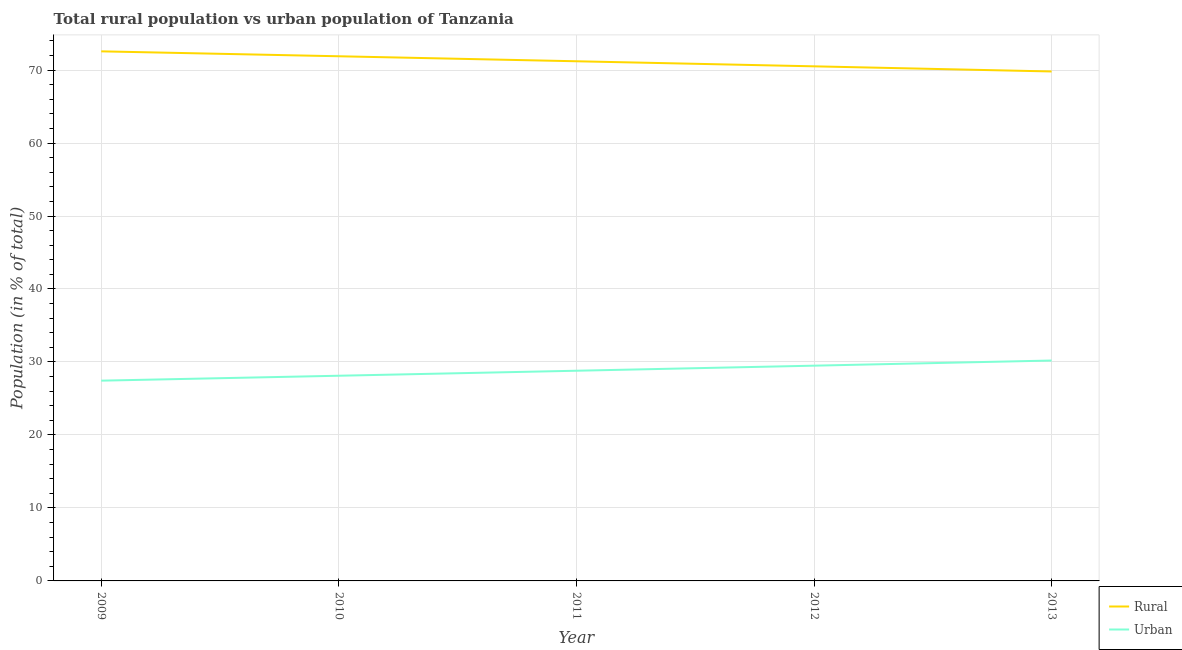Does the line corresponding to rural population intersect with the line corresponding to urban population?
Offer a very short reply. No. Is the number of lines equal to the number of legend labels?
Your response must be concise. Yes. What is the urban population in 2013?
Provide a succinct answer. 30.2. Across all years, what is the maximum rural population?
Offer a terse response. 72.56. Across all years, what is the minimum urban population?
Provide a succinct answer. 27.44. In which year was the rural population minimum?
Your answer should be compact. 2013. What is the total urban population in the graph?
Provide a succinct answer. 144.04. What is the difference between the urban population in 2009 and that in 2013?
Your answer should be compact. -2.76. What is the difference between the urban population in 2013 and the rural population in 2011?
Ensure brevity in your answer.  -41.01. What is the average rural population per year?
Your answer should be compact. 71.19. In the year 2013, what is the difference between the rural population and urban population?
Keep it short and to the point. 39.61. What is the ratio of the urban population in 2012 to that in 2013?
Provide a succinct answer. 0.98. Is the urban population in 2010 less than that in 2012?
Give a very brief answer. Yes. What is the difference between the highest and the second highest rural population?
Offer a very short reply. 0.67. What is the difference between the highest and the lowest rural population?
Keep it short and to the point. 2.76. Does the rural population monotonically increase over the years?
Give a very brief answer. No. Is the rural population strictly greater than the urban population over the years?
Offer a very short reply. Yes. Is the rural population strictly less than the urban population over the years?
Offer a very short reply. No. What is the difference between two consecutive major ticks on the Y-axis?
Your answer should be compact. 10. Are the values on the major ticks of Y-axis written in scientific E-notation?
Offer a very short reply. No. Does the graph contain any zero values?
Your answer should be very brief. No. What is the title of the graph?
Keep it short and to the point. Total rural population vs urban population of Tanzania. What is the label or title of the Y-axis?
Give a very brief answer. Population (in % of total). What is the Population (in % of total) of Rural in 2009?
Your response must be concise. 72.56. What is the Population (in % of total) in Urban in 2009?
Give a very brief answer. 27.44. What is the Population (in % of total) in Rural in 2010?
Your answer should be compact. 71.89. What is the Population (in % of total) in Urban in 2010?
Provide a short and direct response. 28.11. What is the Population (in % of total) of Rural in 2011?
Your response must be concise. 71.2. What is the Population (in % of total) of Urban in 2011?
Keep it short and to the point. 28.8. What is the Population (in % of total) of Rural in 2012?
Keep it short and to the point. 70.51. What is the Population (in % of total) of Urban in 2012?
Give a very brief answer. 29.49. What is the Population (in % of total) in Rural in 2013?
Give a very brief answer. 69.8. What is the Population (in % of total) in Urban in 2013?
Your response must be concise. 30.2. Across all years, what is the maximum Population (in % of total) of Rural?
Provide a succinct answer. 72.56. Across all years, what is the maximum Population (in % of total) in Urban?
Provide a short and direct response. 30.2. Across all years, what is the minimum Population (in % of total) of Rural?
Make the answer very short. 69.8. Across all years, what is the minimum Population (in % of total) of Urban?
Your answer should be compact. 27.44. What is the total Population (in % of total) of Rural in the graph?
Ensure brevity in your answer.  355.96. What is the total Population (in % of total) in Urban in the graph?
Offer a terse response. 144.04. What is the difference between the Population (in % of total) of Rural in 2009 and that in 2010?
Make the answer very short. 0.68. What is the difference between the Population (in % of total) in Urban in 2009 and that in 2010?
Keep it short and to the point. -0.68. What is the difference between the Population (in % of total) of Rural in 2009 and that in 2011?
Make the answer very short. 1.36. What is the difference between the Population (in % of total) of Urban in 2009 and that in 2011?
Your answer should be compact. -1.36. What is the difference between the Population (in % of total) in Rural in 2009 and that in 2012?
Provide a short and direct response. 2.05. What is the difference between the Population (in % of total) in Urban in 2009 and that in 2012?
Ensure brevity in your answer.  -2.05. What is the difference between the Population (in % of total) in Rural in 2009 and that in 2013?
Your response must be concise. 2.76. What is the difference between the Population (in % of total) of Urban in 2009 and that in 2013?
Make the answer very short. -2.76. What is the difference between the Population (in % of total) of Rural in 2010 and that in 2011?
Provide a short and direct response. 0.68. What is the difference between the Population (in % of total) of Urban in 2010 and that in 2011?
Keep it short and to the point. -0.68. What is the difference between the Population (in % of total) of Rural in 2010 and that in 2012?
Offer a very short reply. 1.38. What is the difference between the Population (in % of total) of Urban in 2010 and that in 2012?
Make the answer very short. -1.38. What is the difference between the Population (in % of total) of Rural in 2010 and that in 2013?
Give a very brief answer. 2.08. What is the difference between the Population (in % of total) in Urban in 2010 and that in 2013?
Provide a short and direct response. -2.08. What is the difference between the Population (in % of total) of Rural in 2011 and that in 2012?
Offer a very short reply. 0.69. What is the difference between the Population (in % of total) in Urban in 2011 and that in 2012?
Give a very brief answer. -0.69. What is the difference between the Population (in % of total) in Rural in 2011 and that in 2013?
Give a very brief answer. 1.4. What is the difference between the Population (in % of total) of Urban in 2011 and that in 2013?
Your answer should be very brief. -1.4. What is the difference between the Population (in % of total) of Rural in 2012 and that in 2013?
Ensure brevity in your answer.  0.7. What is the difference between the Population (in % of total) of Urban in 2012 and that in 2013?
Offer a terse response. -0.7. What is the difference between the Population (in % of total) in Rural in 2009 and the Population (in % of total) in Urban in 2010?
Provide a succinct answer. 44.45. What is the difference between the Population (in % of total) of Rural in 2009 and the Population (in % of total) of Urban in 2011?
Make the answer very short. 43.76. What is the difference between the Population (in % of total) in Rural in 2009 and the Population (in % of total) in Urban in 2012?
Offer a terse response. 43.07. What is the difference between the Population (in % of total) of Rural in 2009 and the Population (in % of total) of Urban in 2013?
Provide a short and direct response. 42.37. What is the difference between the Population (in % of total) of Rural in 2010 and the Population (in % of total) of Urban in 2011?
Keep it short and to the point. 43.09. What is the difference between the Population (in % of total) in Rural in 2010 and the Population (in % of total) in Urban in 2012?
Provide a succinct answer. 42.39. What is the difference between the Population (in % of total) of Rural in 2010 and the Population (in % of total) of Urban in 2013?
Your response must be concise. 41.69. What is the difference between the Population (in % of total) in Rural in 2011 and the Population (in % of total) in Urban in 2012?
Ensure brevity in your answer.  41.71. What is the difference between the Population (in % of total) of Rural in 2011 and the Population (in % of total) of Urban in 2013?
Give a very brief answer. 41.01. What is the difference between the Population (in % of total) in Rural in 2012 and the Population (in % of total) in Urban in 2013?
Provide a succinct answer. 40.31. What is the average Population (in % of total) in Rural per year?
Ensure brevity in your answer.  71.19. What is the average Population (in % of total) in Urban per year?
Ensure brevity in your answer.  28.81. In the year 2009, what is the difference between the Population (in % of total) in Rural and Population (in % of total) in Urban?
Your response must be concise. 45.12. In the year 2010, what is the difference between the Population (in % of total) of Rural and Population (in % of total) of Urban?
Offer a terse response. 43.77. In the year 2011, what is the difference between the Population (in % of total) of Rural and Population (in % of total) of Urban?
Offer a very short reply. 42.4. In the year 2012, what is the difference between the Population (in % of total) in Rural and Population (in % of total) in Urban?
Your answer should be compact. 41.01. In the year 2013, what is the difference between the Population (in % of total) of Rural and Population (in % of total) of Urban?
Ensure brevity in your answer.  39.61. What is the ratio of the Population (in % of total) of Rural in 2009 to that in 2010?
Your response must be concise. 1.01. What is the ratio of the Population (in % of total) in Urban in 2009 to that in 2010?
Your response must be concise. 0.98. What is the ratio of the Population (in % of total) in Rural in 2009 to that in 2011?
Offer a terse response. 1.02. What is the ratio of the Population (in % of total) of Urban in 2009 to that in 2011?
Ensure brevity in your answer.  0.95. What is the ratio of the Population (in % of total) in Rural in 2009 to that in 2012?
Keep it short and to the point. 1.03. What is the ratio of the Population (in % of total) of Urban in 2009 to that in 2012?
Provide a short and direct response. 0.93. What is the ratio of the Population (in % of total) in Rural in 2009 to that in 2013?
Provide a short and direct response. 1.04. What is the ratio of the Population (in % of total) in Urban in 2009 to that in 2013?
Offer a very short reply. 0.91. What is the ratio of the Population (in % of total) in Rural in 2010 to that in 2011?
Give a very brief answer. 1.01. What is the ratio of the Population (in % of total) of Urban in 2010 to that in 2011?
Ensure brevity in your answer.  0.98. What is the ratio of the Population (in % of total) in Rural in 2010 to that in 2012?
Give a very brief answer. 1.02. What is the ratio of the Population (in % of total) of Urban in 2010 to that in 2012?
Your answer should be very brief. 0.95. What is the ratio of the Population (in % of total) in Rural in 2010 to that in 2013?
Provide a short and direct response. 1.03. What is the ratio of the Population (in % of total) of Urban in 2010 to that in 2013?
Provide a short and direct response. 0.93. What is the ratio of the Population (in % of total) in Rural in 2011 to that in 2012?
Provide a succinct answer. 1.01. What is the ratio of the Population (in % of total) in Urban in 2011 to that in 2012?
Provide a succinct answer. 0.98. What is the ratio of the Population (in % of total) of Urban in 2011 to that in 2013?
Your answer should be compact. 0.95. What is the ratio of the Population (in % of total) of Rural in 2012 to that in 2013?
Offer a terse response. 1.01. What is the ratio of the Population (in % of total) of Urban in 2012 to that in 2013?
Offer a terse response. 0.98. What is the difference between the highest and the second highest Population (in % of total) in Rural?
Ensure brevity in your answer.  0.68. What is the difference between the highest and the second highest Population (in % of total) in Urban?
Make the answer very short. 0.7. What is the difference between the highest and the lowest Population (in % of total) in Rural?
Keep it short and to the point. 2.76. What is the difference between the highest and the lowest Population (in % of total) of Urban?
Provide a succinct answer. 2.76. 